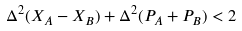Convert formula to latex. <formula><loc_0><loc_0><loc_500><loc_500>\Delta ^ { 2 } ( X _ { A } - X _ { B } ) + \Delta ^ { 2 } ( P _ { A } + P _ { B } ) < 2 \,</formula> 